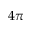<formula> <loc_0><loc_0><loc_500><loc_500>4 \pi</formula> 